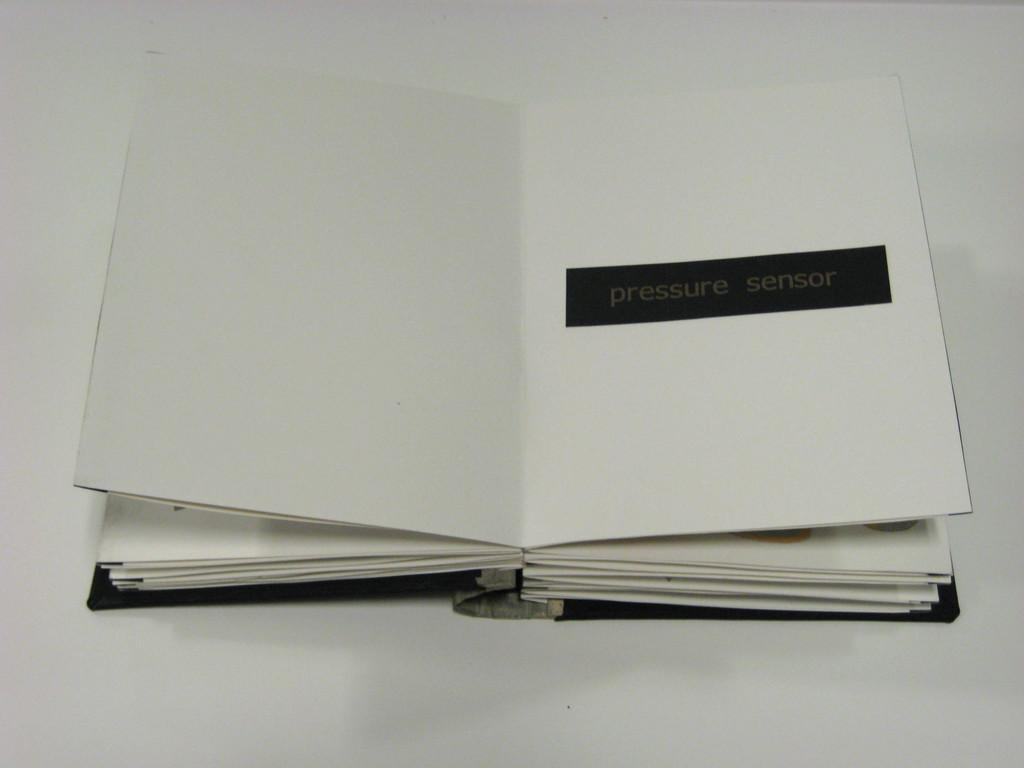<image>
Create a compact narrative representing the image presented. a book opened to nothing but a worded banner that says pressure sensor on the right hand side. 